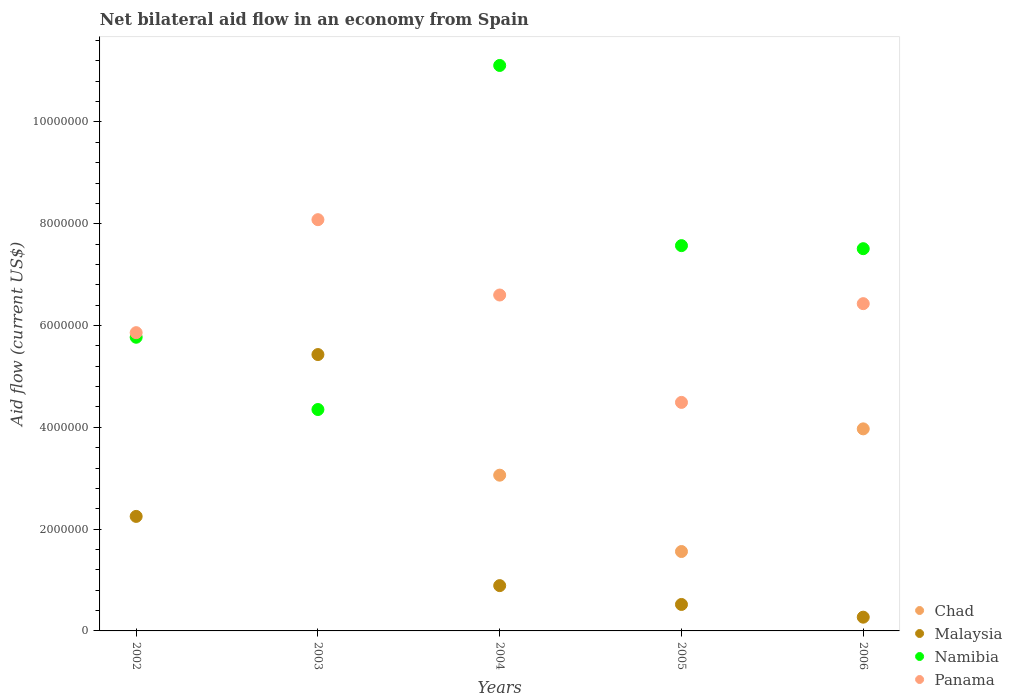What is the net bilateral aid flow in Chad in 2004?
Provide a short and direct response. 3.06e+06. Across all years, what is the maximum net bilateral aid flow in Malaysia?
Your answer should be very brief. 5.43e+06. Across all years, what is the minimum net bilateral aid flow in Namibia?
Make the answer very short. 4.35e+06. In which year was the net bilateral aid flow in Malaysia maximum?
Offer a very short reply. 2003. What is the total net bilateral aid flow in Chad in the graph?
Keep it short and to the point. 8.59e+06. What is the difference between the net bilateral aid flow in Panama in 2003 and that in 2006?
Offer a very short reply. 1.65e+06. What is the difference between the net bilateral aid flow in Namibia in 2006 and the net bilateral aid flow in Malaysia in 2003?
Provide a short and direct response. 2.08e+06. What is the average net bilateral aid flow in Namibia per year?
Provide a succinct answer. 7.26e+06. In the year 2006, what is the difference between the net bilateral aid flow in Panama and net bilateral aid flow in Chad?
Keep it short and to the point. 2.46e+06. In how many years, is the net bilateral aid flow in Malaysia greater than 8400000 US$?
Keep it short and to the point. 0. What is the ratio of the net bilateral aid flow in Malaysia in 2002 to that in 2004?
Keep it short and to the point. 2.53. Is the difference between the net bilateral aid flow in Panama in 2005 and 2006 greater than the difference between the net bilateral aid flow in Chad in 2005 and 2006?
Make the answer very short. Yes. What is the difference between the highest and the second highest net bilateral aid flow in Malaysia?
Ensure brevity in your answer.  3.18e+06. What is the difference between the highest and the lowest net bilateral aid flow in Panama?
Your answer should be very brief. 3.59e+06. Is the sum of the net bilateral aid flow in Malaysia in 2004 and 2006 greater than the maximum net bilateral aid flow in Namibia across all years?
Keep it short and to the point. No. Is it the case that in every year, the sum of the net bilateral aid flow in Panama and net bilateral aid flow in Chad  is greater than the sum of net bilateral aid flow in Malaysia and net bilateral aid flow in Namibia?
Make the answer very short. Yes. Is it the case that in every year, the sum of the net bilateral aid flow in Malaysia and net bilateral aid flow in Namibia  is greater than the net bilateral aid flow in Chad?
Your answer should be compact. Yes. Does the net bilateral aid flow in Malaysia monotonically increase over the years?
Keep it short and to the point. No. Is the net bilateral aid flow in Panama strictly greater than the net bilateral aid flow in Chad over the years?
Offer a very short reply. Yes. How many years are there in the graph?
Your answer should be very brief. 5. What is the difference between two consecutive major ticks on the Y-axis?
Make the answer very short. 2.00e+06. Are the values on the major ticks of Y-axis written in scientific E-notation?
Provide a succinct answer. No. Does the graph contain grids?
Your answer should be compact. No. How many legend labels are there?
Ensure brevity in your answer.  4. What is the title of the graph?
Your response must be concise. Net bilateral aid flow in an economy from Spain. What is the Aid flow (current US$) of Chad in 2002?
Offer a very short reply. 0. What is the Aid flow (current US$) of Malaysia in 2002?
Provide a succinct answer. 2.25e+06. What is the Aid flow (current US$) of Namibia in 2002?
Provide a succinct answer. 5.77e+06. What is the Aid flow (current US$) in Panama in 2002?
Give a very brief answer. 5.86e+06. What is the Aid flow (current US$) in Malaysia in 2003?
Your answer should be compact. 5.43e+06. What is the Aid flow (current US$) of Namibia in 2003?
Provide a succinct answer. 4.35e+06. What is the Aid flow (current US$) in Panama in 2003?
Ensure brevity in your answer.  8.08e+06. What is the Aid flow (current US$) of Chad in 2004?
Your answer should be very brief. 3.06e+06. What is the Aid flow (current US$) in Malaysia in 2004?
Provide a short and direct response. 8.90e+05. What is the Aid flow (current US$) in Namibia in 2004?
Keep it short and to the point. 1.11e+07. What is the Aid flow (current US$) of Panama in 2004?
Offer a very short reply. 6.60e+06. What is the Aid flow (current US$) of Chad in 2005?
Offer a very short reply. 1.56e+06. What is the Aid flow (current US$) in Malaysia in 2005?
Provide a succinct answer. 5.20e+05. What is the Aid flow (current US$) of Namibia in 2005?
Your answer should be very brief. 7.57e+06. What is the Aid flow (current US$) in Panama in 2005?
Your response must be concise. 4.49e+06. What is the Aid flow (current US$) of Chad in 2006?
Keep it short and to the point. 3.97e+06. What is the Aid flow (current US$) in Malaysia in 2006?
Provide a short and direct response. 2.70e+05. What is the Aid flow (current US$) of Namibia in 2006?
Offer a terse response. 7.51e+06. What is the Aid flow (current US$) in Panama in 2006?
Offer a very short reply. 6.43e+06. Across all years, what is the maximum Aid flow (current US$) in Chad?
Provide a short and direct response. 3.97e+06. Across all years, what is the maximum Aid flow (current US$) of Malaysia?
Keep it short and to the point. 5.43e+06. Across all years, what is the maximum Aid flow (current US$) in Namibia?
Offer a very short reply. 1.11e+07. Across all years, what is the maximum Aid flow (current US$) of Panama?
Your answer should be very brief. 8.08e+06. Across all years, what is the minimum Aid flow (current US$) of Chad?
Your answer should be very brief. 0. Across all years, what is the minimum Aid flow (current US$) of Namibia?
Keep it short and to the point. 4.35e+06. Across all years, what is the minimum Aid flow (current US$) in Panama?
Ensure brevity in your answer.  4.49e+06. What is the total Aid flow (current US$) of Chad in the graph?
Provide a short and direct response. 8.59e+06. What is the total Aid flow (current US$) in Malaysia in the graph?
Ensure brevity in your answer.  9.36e+06. What is the total Aid flow (current US$) of Namibia in the graph?
Provide a short and direct response. 3.63e+07. What is the total Aid flow (current US$) in Panama in the graph?
Ensure brevity in your answer.  3.15e+07. What is the difference between the Aid flow (current US$) in Malaysia in 2002 and that in 2003?
Make the answer very short. -3.18e+06. What is the difference between the Aid flow (current US$) of Namibia in 2002 and that in 2003?
Ensure brevity in your answer.  1.42e+06. What is the difference between the Aid flow (current US$) of Panama in 2002 and that in 2003?
Give a very brief answer. -2.22e+06. What is the difference between the Aid flow (current US$) of Malaysia in 2002 and that in 2004?
Give a very brief answer. 1.36e+06. What is the difference between the Aid flow (current US$) in Namibia in 2002 and that in 2004?
Make the answer very short. -5.34e+06. What is the difference between the Aid flow (current US$) of Panama in 2002 and that in 2004?
Keep it short and to the point. -7.40e+05. What is the difference between the Aid flow (current US$) of Malaysia in 2002 and that in 2005?
Offer a very short reply. 1.73e+06. What is the difference between the Aid flow (current US$) of Namibia in 2002 and that in 2005?
Ensure brevity in your answer.  -1.80e+06. What is the difference between the Aid flow (current US$) in Panama in 2002 and that in 2005?
Provide a succinct answer. 1.37e+06. What is the difference between the Aid flow (current US$) of Malaysia in 2002 and that in 2006?
Your response must be concise. 1.98e+06. What is the difference between the Aid flow (current US$) of Namibia in 2002 and that in 2006?
Provide a succinct answer. -1.74e+06. What is the difference between the Aid flow (current US$) of Panama in 2002 and that in 2006?
Give a very brief answer. -5.70e+05. What is the difference between the Aid flow (current US$) of Malaysia in 2003 and that in 2004?
Offer a very short reply. 4.54e+06. What is the difference between the Aid flow (current US$) of Namibia in 2003 and that in 2004?
Provide a succinct answer. -6.76e+06. What is the difference between the Aid flow (current US$) in Panama in 2003 and that in 2004?
Make the answer very short. 1.48e+06. What is the difference between the Aid flow (current US$) of Malaysia in 2003 and that in 2005?
Provide a short and direct response. 4.91e+06. What is the difference between the Aid flow (current US$) of Namibia in 2003 and that in 2005?
Your response must be concise. -3.22e+06. What is the difference between the Aid flow (current US$) of Panama in 2003 and that in 2005?
Provide a succinct answer. 3.59e+06. What is the difference between the Aid flow (current US$) of Malaysia in 2003 and that in 2006?
Offer a terse response. 5.16e+06. What is the difference between the Aid flow (current US$) in Namibia in 2003 and that in 2006?
Provide a succinct answer. -3.16e+06. What is the difference between the Aid flow (current US$) in Panama in 2003 and that in 2006?
Offer a very short reply. 1.65e+06. What is the difference between the Aid flow (current US$) of Chad in 2004 and that in 2005?
Keep it short and to the point. 1.50e+06. What is the difference between the Aid flow (current US$) in Malaysia in 2004 and that in 2005?
Provide a succinct answer. 3.70e+05. What is the difference between the Aid flow (current US$) in Namibia in 2004 and that in 2005?
Keep it short and to the point. 3.54e+06. What is the difference between the Aid flow (current US$) of Panama in 2004 and that in 2005?
Provide a succinct answer. 2.11e+06. What is the difference between the Aid flow (current US$) in Chad in 2004 and that in 2006?
Your answer should be very brief. -9.10e+05. What is the difference between the Aid flow (current US$) in Malaysia in 2004 and that in 2006?
Ensure brevity in your answer.  6.20e+05. What is the difference between the Aid flow (current US$) of Namibia in 2004 and that in 2006?
Your answer should be compact. 3.60e+06. What is the difference between the Aid flow (current US$) in Panama in 2004 and that in 2006?
Offer a terse response. 1.70e+05. What is the difference between the Aid flow (current US$) of Chad in 2005 and that in 2006?
Provide a succinct answer. -2.41e+06. What is the difference between the Aid flow (current US$) in Panama in 2005 and that in 2006?
Provide a succinct answer. -1.94e+06. What is the difference between the Aid flow (current US$) in Malaysia in 2002 and the Aid flow (current US$) in Namibia in 2003?
Offer a terse response. -2.10e+06. What is the difference between the Aid flow (current US$) of Malaysia in 2002 and the Aid flow (current US$) of Panama in 2003?
Ensure brevity in your answer.  -5.83e+06. What is the difference between the Aid flow (current US$) of Namibia in 2002 and the Aid flow (current US$) of Panama in 2003?
Provide a short and direct response. -2.31e+06. What is the difference between the Aid flow (current US$) of Malaysia in 2002 and the Aid flow (current US$) of Namibia in 2004?
Offer a very short reply. -8.86e+06. What is the difference between the Aid flow (current US$) of Malaysia in 2002 and the Aid flow (current US$) of Panama in 2004?
Give a very brief answer. -4.35e+06. What is the difference between the Aid flow (current US$) in Namibia in 2002 and the Aid flow (current US$) in Panama in 2004?
Make the answer very short. -8.30e+05. What is the difference between the Aid flow (current US$) of Malaysia in 2002 and the Aid flow (current US$) of Namibia in 2005?
Ensure brevity in your answer.  -5.32e+06. What is the difference between the Aid flow (current US$) of Malaysia in 2002 and the Aid flow (current US$) of Panama in 2005?
Provide a short and direct response. -2.24e+06. What is the difference between the Aid flow (current US$) in Namibia in 2002 and the Aid flow (current US$) in Panama in 2005?
Keep it short and to the point. 1.28e+06. What is the difference between the Aid flow (current US$) of Malaysia in 2002 and the Aid flow (current US$) of Namibia in 2006?
Give a very brief answer. -5.26e+06. What is the difference between the Aid flow (current US$) of Malaysia in 2002 and the Aid flow (current US$) of Panama in 2006?
Provide a short and direct response. -4.18e+06. What is the difference between the Aid flow (current US$) in Namibia in 2002 and the Aid flow (current US$) in Panama in 2006?
Provide a short and direct response. -6.60e+05. What is the difference between the Aid flow (current US$) of Malaysia in 2003 and the Aid flow (current US$) of Namibia in 2004?
Provide a short and direct response. -5.68e+06. What is the difference between the Aid flow (current US$) in Malaysia in 2003 and the Aid flow (current US$) in Panama in 2004?
Provide a succinct answer. -1.17e+06. What is the difference between the Aid flow (current US$) in Namibia in 2003 and the Aid flow (current US$) in Panama in 2004?
Ensure brevity in your answer.  -2.25e+06. What is the difference between the Aid flow (current US$) of Malaysia in 2003 and the Aid flow (current US$) of Namibia in 2005?
Keep it short and to the point. -2.14e+06. What is the difference between the Aid flow (current US$) in Malaysia in 2003 and the Aid flow (current US$) in Panama in 2005?
Ensure brevity in your answer.  9.40e+05. What is the difference between the Aid flow (current US$) of Namibia in 2003 and the Aid flow (current US$) of Panama in 2005?
Give a very brief answer. -1.40e+05. What is the difference between the Aid flow (current US$) in Malaysia in 2003 and the Aid flow (current US$) in Namibia in 2006?
Provide a short and direct response. -2.08e+06. What is the difference between the Aid flow (current US$) in Malaysia in 2003 and the Aid flow (current US$) in Panama in 2006?
Make the answer very short. -1.00e+06. What is the difference between the Aid flow (current US$) of Namibia in 2003 and the Aid flow (current US$) of Panama in 2006?
Keep it short and to the point. -2.08e+06. What is the difference between the Aid flow (current US$) of Chad in 2004 and the Aid flow (current US$) of Malaysia in 2005?
Your answer should be compact. 2.54e+06. What is the difference between the Aid flow (current US$) of Chad in 2004 and the Aid flow (current US$) of Namibia in 2005?
Offer a terse response. -4.51e+06. What is the difference between the Aid flow (current US$) in Chad in 2004 and the Aid flow (current US$) in Panama in 2005?
Provide a short and direct response. -1.43e+06. What is the difference between the Aid flow (current US$) in Malaysia in 2004 and the Aid flow (current US$) in Namibia in 2005?
Offer a very short reply. -6.68e+06. What is the difference between the Aid flow (current US$) of Malaysia in 2004 and the Aid flow (current US$) of Panama in 2005?
Offer a terse response. -3.60e+06. What is the difference between the Aid flow (current US$) in Namibia in 2004 and the Aid flow (current US$) in Panama in 2005?
Provide a succinct answer. 6.62e+06. What is the difference between the Aid flow (current US$) in Chad in 2004 and the Aid flow (current US$) in Malaysia in 2006?
Provide a short and direct response. 2.79e+06. What is the difference between the Aid flow (current US$) in Chad in 2004 and the Aid flow (current US$) in Namibia in 2006?
Make the answer very short. -4.45e+06. What is the difference between the Aid flow (current US$) of Chad in 2004 and the Aid flow (current US$) of Panama in 2006?
Keep it short and to the point. -3.37e+06. What is the difference between the Aid flow (current US$) in Malaysia in 2004 and the Aid flow (current US$) in Namibia in 2006?
Keep it short and to the point. -6.62e+06. What is the difference between the Aid flow (current US$) in Malaysia in 2004 and the Aid flow (current US$) in Panama in 2006?
Provide a succinct answer. -5.54e+06. What is the difference between the Aid flow (current US$) in Namibia in 2004 and the Aid flow (current US$) in Panama in 2006?
Provide a succinct answer. 4.68e+06. What is the difference between the Aid flow (current US$) in Chad in 2005 and the Aid flow (current US$) in Malaysia in 2006?
Ensure brevity in your answer.  1.29e+06. What is the difference between the Aid flow (current US$) in Chad in 2005 and the Aid flow (current US$) in Namibia in 2006?
Provide a succinct answer. -5.95e+06. What is the difference between the Aid flow (current US$) in Chad in 2005 and the Aid flow (current US$) in Panama in 2006?
Give a very brief answer. -4.87e+06. What is the difference between the Aid flow (current US$) of Malaysia in 2005 and the Aid flow (current US$) of Namibia in 2006?
Offer a very short reply. -6.99e+06. What is the difference between the Aid flow (current US$) of Malaysia in 2005 and the Aid flow (current US$) of Panama in 2006?
Provide a succinct answer. -5.91e+06. What is the difference between the Aid flow (current US$) in Namibia in 2005 and the Aid flow (current US$) in Panama in 2006?
Provide a short and direct response. 1.14e+06. What is the average Aid flow (current US$) of Chad per year?
Offer a terse response. 1.72e+06. What is the average Aid flow (current US$) of Malaysia per year?
Offer a very short reply. 1.87e+06. What is the average Aid flow (current US$) in Namibia per year?
Offer a very short reply. 7.26e+06. What is the average Aid flow (current US$) of Panama per year?
Your answer should be compact. 6.29e+06. In the year 2002, what is the difference between the Aid flow (current US$) of Malaysia and Aid flow (current US$) of Namibia?
Offer a very short reply. -3.52e+06. In the year 2002, what is the difference between the Aid flow (current US$) in Malaysia and Aid flow (current US$) in Panama?
Your response must be concise. -3.61e+06. In the year 2003, what is the difference between the Aid flow (current US$) of Malaysia and Aid flow (current US$) of Namibia?
Give a very brief answer. 1.08e+06. In the year 2003, what is the difference between the Aid flow (current US$) in Malaysia and Aid flow (current US$) in Panama?
Keep it short and to the point. -2.65e+06. In the year 2003, what is the difference between the Aid flow (current US$) of Namibia and Aid flow (current US$) of Panama?
Your answer should be compact. -3.73e+06. In the year 2004, what is the difference between the Aid flow (current US$) of Chad and Aid flow (current US$) of Malaysia?
Offer a terse response. 2.17e+06. In the year 2004, what is the difference between the Aid flow (current US$) of Chad and Aid flow (current US$) of Namibia?
Your answer should be very brief. -8.05e+06. In the year 2004, what is the difference between the Aid flow (current US$) of Chad and Aid flow (current US$) of Panama?
Provide a short and direct response. -3.54e+06. In the year 2004, what is the difference between the Aid flow (current US$) in Malaysia and Aid flow (current US$) in Namibia?
Give a very brief answer. -1.02e+07. In the year 2004, what is the difference between the Aid flow (current US$) in Malaysia and Aid flow (current US$) in Panama?
Offer a terse response. -5.71e+06. In the year 2004, what is the difference between the Aid flow (current US$) of Namibia and Aid flow (current US$) of Panama?
Your response must be concise. 4.51e+06. In the year 2005, what is the difference between the Aid flow (current US$) of Chad and Aid flow (current US$) of Malaysia?
Your answer should be very brief. 1.04e+06. In the year 2005, what is the difference between the Aid flow (current US$) of Chad and Aid flow (current US$) of Namibia?
Offer a terse response. -6.01e+06. In the year 2005, what is the difference between the Aid flow (current US$) in Chad and Aid flow (current US$) in Panama?
Provide a short and direct response. -2.93e+06. In the year 2005, what is the difference between the Aid flow (current US$) in Malaysia and Aid flow (current US$) in Namibia?
Provide a succinct answer. -7.05e+06. In the year 2005, what is the difference between the Aid flow (current US$) of Malaysia and Aid flow (current US$) of Panama?
Provide a short and direct response. -3.97e+06. In the year 2005, what is the difference between the Aid flow (current US$) of Namibia and Aid flow (current US$) of Panama?
Your answer should be very brief. 3.08e+06. In the year 2006, what is the difference between the Aid flow (current US$) of Chad and Aid flow (current US$) of Malaysia?
Make the answer very short. 3.70e+06. In the year 2006, what is the difference between the Aid flow (current US$) of Chad and Aid flow (current US$) of Namibia?
Provide a succinct answer. -3.54e+06. In the year 2006, what is the difference between the Aid flow (current US$) of Chad and Aid flow (current US$) of Panama?
Your response must be concise. -2.46e+06. In the year 2006, what is the difference between the Aid flow (current US$) of Malaysia and Aid flow (current US$) of Namibia?
Your answer should be compact. -7.24e+06. In the year 2006, what is the difference between the Aid flow (current US$) of Malaysia and Aid flow (current US$) of Panama?
Make the answer very short. -6.16e+06. In the year 2006, what is the difference between the Aid flow (current US$) of Namibia and Aid flow (current US$) of Panama?
Give a very brief answer. 1.08e+06. What is the ratio of the Aid flow (current US$) in Malaysia in 2002 to that in 2003?
Provide a short and direct response. 0.41. What is the ratio of the Aid flow (current US$) in Namibia in 2002 to that in 2003?
Provide a succinct answer. 1.33. What is the ratio of the Aid flow (current US$) in Panama in 2002 to that in 2003?
Your response must be concise. 0.73. What is the ratio of the Aid flow (current US$) in Malaysia in 2002 to that in 2004?
Your answer should be compact. 2.53. What is the ratio of the Aid flow (current US$) in Namibia in 2002 to that in 2004?
Make the answer very short. 0.52. What is the ratio of the Aid flow (current US$) of Panama in 2002 to that in 2004?
Your answer should be compact. 0.89. What is the ratio of the Aid flow (current US$) of Malaysia in 2002 to that in 2005?
Give a very brief answer. 4.33. What is the ratio of the Aid flow (current US$) of Namibia in 2002 to that in 2005?
Make the answer very short. 0.76. What is the ratio of the Aid flow (current US$) of Panama in 2002 to that in 2005?
Offer a very short reply. 1.31. What is the ratio of the Aid flow (current US$) in Malaysia in 2002 to that in 2006?
Ensure brevity in your answer.  8.33. What is the ratio of the Aid flow (current US$) of Namibia in 2002 to that in 2006?
Make the answer very short. 0.77. What is the ratio of the Aid flow (current US$) of Panama in 2002 to that in 2006?
Make the answer very short. 0.91. What is the ratio of the Aid flow (current US$) in Malaysia in 2003 to that in 2004?
Provide a short and direct response. 6.1. What is the ratio of the Aid flow (current US$) in Namibia in 2003 to that in 2004?
Give a very brief answer. 0.39. What is the ratio of the Aid flow (current US$) of Panama in 2003 to that in 2004?
Your response must be concise. 1.22. What is the ratio of the Aid flow (current US$) of Malaysia in 2003 to that in 2005?
Your response must be concise. 10.44. What is the ratio of the Aid flow (current US$) of Namibia in 2003 to that in 2005?
Offer a very short reply. 0.57. What is the ratio of the Aid flow (current US$) in Panama in 2003 to that in 2005?
Keep it short and to the point. 1.8. What is the ratio of the Aid flow (current US$) of Malaysia in 2003 to that in 2006?
Provide a succinct answer. 20.11. What is the ratio of the Aid flow (current US$) in Namibia in 2003 to that in 2006?
Your answer should be compact. 0.58. What is the ratio of the Aid flow (current US$) in Panama in 2003 to that in 2006?
Make the answer very short. 1.26. What is the ratio of the Aid flow (current US$) of Chad in 2004 to that in 2005?
Your answer should be very brief. 1.96. What is the ratio of the Aid flow (current US$) in Malaysia in 2004 to that in 2005?
Give a very brief answer. 1.71. What is the ratio of the Aid flow (current US$) in Namibia in 2004 to that in 2005?
Keep it short and to the point. 1.47. What is the ratio of the Aid flow (current US$) of Panama in 2004 to that in 2005?
Your response must be concise. 1.47. What is the ratio of the Aid flow (current US$) of Chad in 2004 to that in 2006?
Make the answer very short. 0.77. What is the ratio of the Aid flow (current US$) of Malaysia in 2004 to that in 2006?
Your answer should be very brief. 3.3. What is the ratio of the Aid flow (current US$) of Namibia in 2004 to that in 2006?
Your response must be concise. 1.48. What is the ratio of the Aid flow (current US$) of Panama in 2004 to that in 2006?
Offer a very short reply. 1.03. What is the ratio of the Aid flow (current US$) of Chad in 2005 to that in 2006?
Your response must be concise. 0.39. What is the ratio of the Aid flow (current US$) of Malaysia in 2005 to that in 2006?
Ensure brevity in your answer.  1.93. What is the ratio of the Aid flow (current US$) of Namibia in 2005 to that in 2006?
Offer a terse response. 1.01. What is the ratio of the Aid flow (current US$) of Panama in 2005 to that in 2006?
Provide a succinct answer. 0.7. What is the difference between the highest and the second highest Aid flow (current US$) in Chad?
Your response must be concise. 9.10e+05. What is the difference between the highest and the second highest Aid flow (current US$) of Malaysia?
Your answer should be very brief. 3.18e+06. What is the difference between the highest and the second highest Aid flow (current US$) of Namibia?
Ensure brevity in your answer.  3.54e+06. What is the difference between the highest and the second highest Aid flow (current US$) in Panama?
Your answer should be compact. 1.48e+06. What is the difference between the highest and the lowest Aid flow (current US$) of Chad?
Provide a short and direct response. 3.97e+06. What is the difference between the highest and the lowest Aid flow (current US$) in Malaysia?
Offer a very short reply. 5.16e+06. What is the difference between the highest and the lowest Aid flow (current US$) in Namibia?
Offer a very short reply. 6.76e+06. What is the difference between the highest and the lowest Aid flow (current US$) in Panama?
Your answer should be very brief. 3.59e+06. 